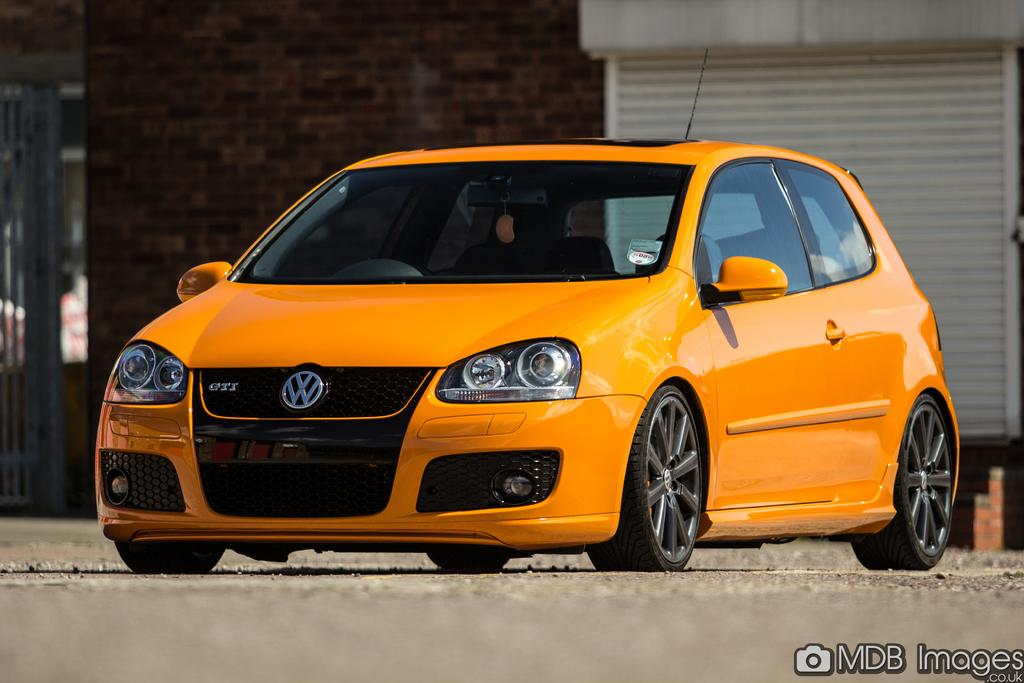What color is the car in the image? The car in the image is orange. Where is the car located in the image? The car is on the road. What can be seen in the background of the image? There is a wall visible in the background of the image. Is there any additional information or marking on the image? Yes, there is a watermark on the bottom right side of the image. What type of base is used to support the wine in the image? There is no wine or base present in the image; it features an orange color car on the road with a wall in the background and a watermark on the bottom right side. 